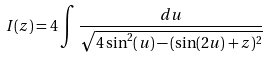<formula> <loc_0><loc_0><loc_500><loc_500>I ( z ) = 4 \int \frac { d u } { \sqrt { 4 \sin ^ { 2 } ( u ) - ( \sin ( 2 u ) + z ) ^ { 2 } } }</formula> 